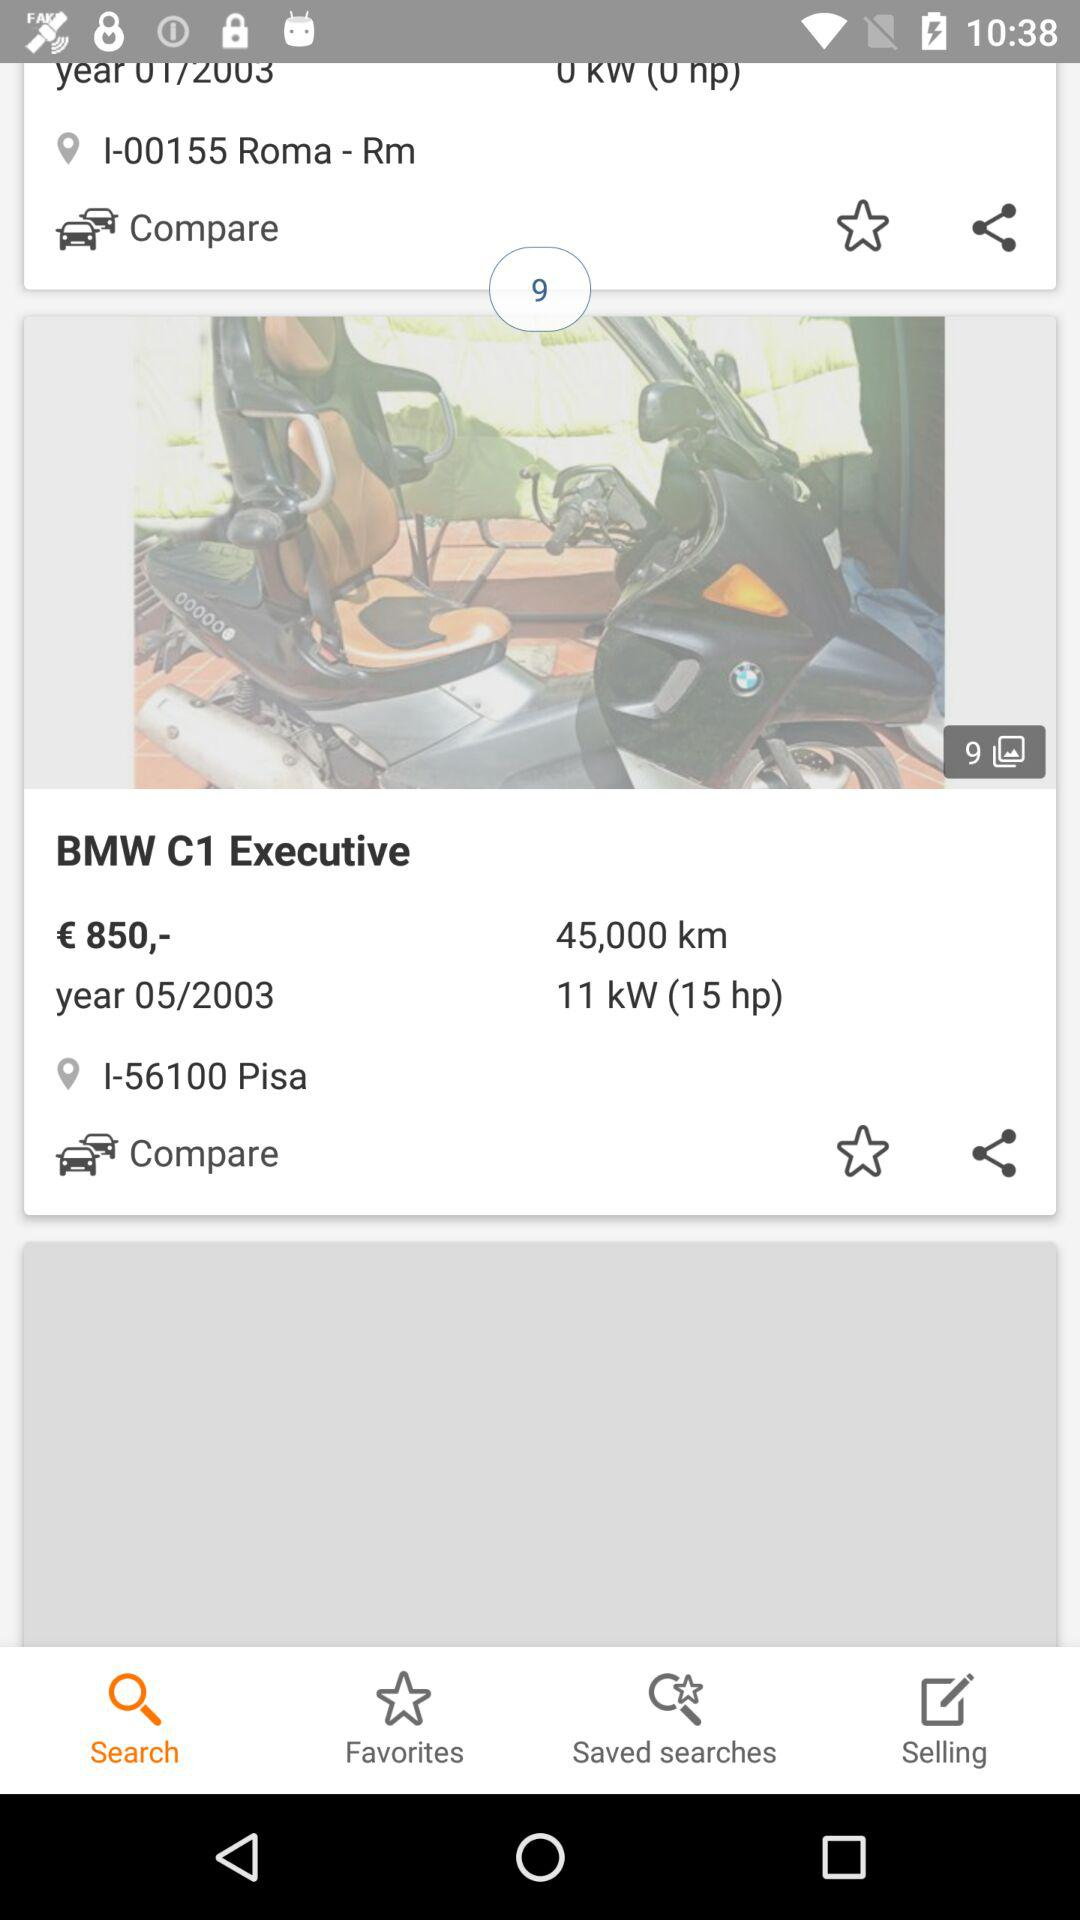Which vehicle has the higher mileage?
Answer the question using a single word or phrase. BMW C1 Executive 